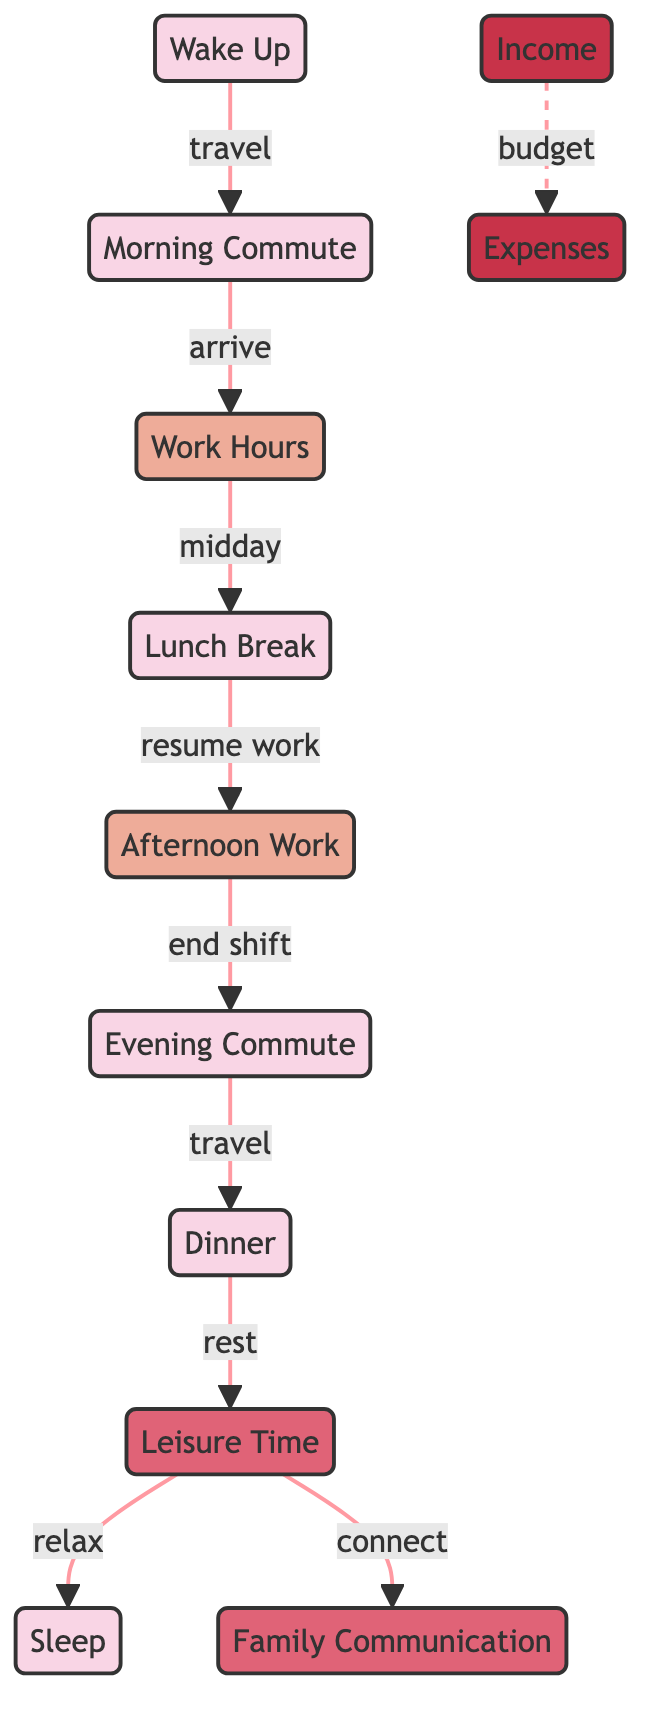What is the first activity in the daily schedule? The diagram indicates that the first activity in the daily schedule is "Wake Up." This is clearly labeled as the starting point before moving to the morning commute.
Answer: Wake Up How many work-related nodes are present in the diagram? There are three work-related nodes in the diagram: "Work Hours," "Lunch Break," and "Afternoon Work." These nodes are specifically marked as related to work activities.
Answer: Three What relationship exists between "Leisure Time" and "Family Communication"? The diagram shows that "Leisure Time" connects to "Family Communication" with the label "connect," indicating that during leisure time, the migrant worker may engage in communication with their family.
Answer: connect What activity follows "Dinner" in the daily schedule? According to the diagram, after "Dinner," the next activity is "Leisure Time," indicating a shift from eating to relaxation and enjoyment.
Answer: Leisure Time Which two nodes are connected by the "travel" label? The nodes connected by the "travel" label are "Evening Commute" and "Dinner." The diagram illustrates a travel activity occurring between these two points in the daily schedule.
Answer: Evening Commute and Dinner What does "Income" relate to in terms of financial aspects? In the diagram, "Income" relates to "Expenses" through a dashed connection labeled "budget." This highlights the relationship between the money earned and the money spent.
Answer: Expenses How many total nodes are present in the diagram? The total number of nodes in the diagram is ten, including all activities and financial considerations, which are each designated specific labels.
Answer: Ten What type of flow does the connection between "Leisure Time" and "Sleep" represent? The connection between "Leisure Time" and "Sleep" represents a flow of "relax," indicating that activities during leisure time lead into a state of rest and sleep.
Answer: relax 